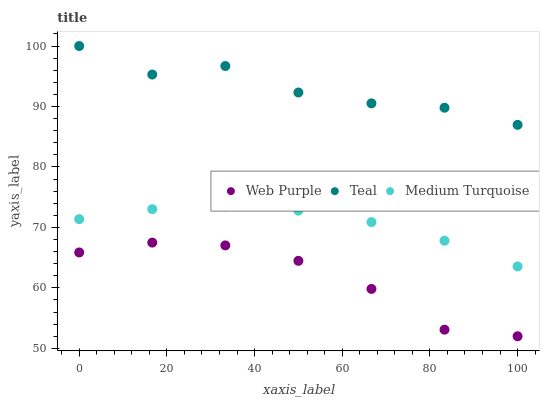Does Web Purple have the minimum area under the curve?
Answer yes or no. Yes. Does Teal have the maximum area under the curve?
Answer yes or no. Yes. Does Medium Turquoise have the minimum area under the curve?
Answer yes or no. No. Does Medium Turquoise have the maximum area under the curve?
Answer yes or no. No. Is Medium Turquoise the smoothest?
Answer yes or no. Yes. Is Teal the roughest?
Answer yes or no. Yes. Is Teal the smoothest?
Answer yes or no. No. Is Medium Turquoise the roughest?
Answer yes or no. No. Does Web Purple have the lowest value?
Answer yes or no. Yes. Does Medium Turquoise have the lowest value?
Answer yes or no. No. Does Teal have the highest value?
Answer yes or no. Yes. Does Medium Turquoise have the highest value?
Answer yes or no. No. Is Web Purple less than Medium Turquoise?
Answer yes or no. Yes. Is Teal greater than Medium Turquoise?
Answer yes or no. Yes. Does Web Purple intersect Medium Turquoise?
Answer yes or no. No. 